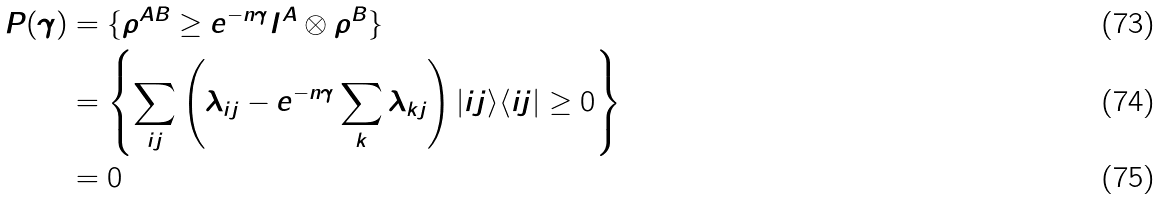Convert formula to latex. <formula><loc_0><loc_0><loc_500><loc_500>P ( \gamma ) & = \{ \rho ^ { A B } \geq e ^ { - n \gamma } I ^ { A } \otimes \rho ^ { B } \} \\ & = \left \{ \sum _ { i j } \left ( \lambda _ { i j } - e ^ { - n \gamma } \sum _ { k } \lambda _ { k j } \right ) | i j \rangle \langle i j | \geq 0 \right \} \\ & = 0</formula> 